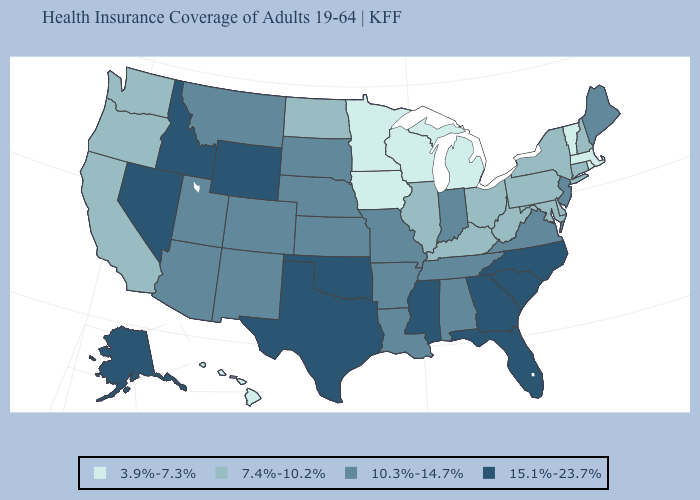Does North Carolina have a higher value than South Dakota?
Keep it brief. Yes. Name the states that have a value in the range 3.9%-7.3%?
Keep it brief. Hawaii, Iowa, Massachusetts, Michigan, Minnesota, Rhode Island, Vermont, Wisconsin. Does Georgia have a higher value than Tennessee?
Give a very brief answer. Yes. What is the value of Louisiana?
Answer briefly. 10.3%-14.7%. What is the value of Nevada?
Be succinct. 15.1%-23.7%. Does Louisiana have a higher value than Nebraska?
Short answer required. No. Name the states that have a value in the range 7.4%-10.2%?
Quick response, please. California, Connecticut, Delaware, Illinois, Kentucky, Maryland, New Hampshire, New York, North Dakota, Ohio, Oregon, Pennsylvania, Washington, West Virginia. Which states have the lowest value in the South?
Concise answer only. Delaware, Kentucky, Maryland, West Virginia. Does the first symbol in the legend represent the smallest category?
Answer briefly. Yes. Does the first symbol in the legend represent the smallest category?
Concise answer only. Yes. What is the value of Rhode Island?
Concise answer only. 3.9%-7.3%. What is the value of Louisiana?
Answer briefly. 10.3%-14.7%. Does Nevada have the highest value in the West?
Concise answer only. Yes. Does Pennsylvania have a lower value than Massachusetts?
Write a very short answer. No. Does the map have missing data?
Concise answer only. No. 